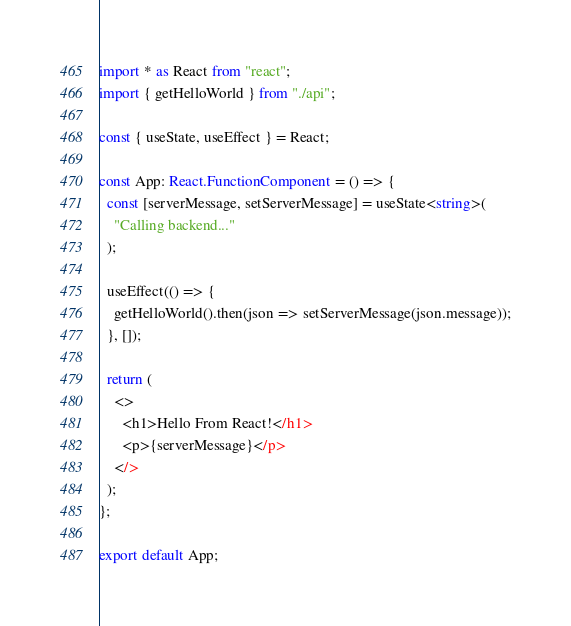<code> <loc_0><loc_0><loc_500><loc_500><_TypeScript_>import * as React from "react";
import { getHelloWorld } from "./api";

const { useState, useEffect } = React;

const App: React.FunctionComponent = () => {
  const [serverMessage, setServerMessage] = useState<string>(
    "Calling backend..."
  );

  useEffect(() => {
    getHelloWorld().then(json => setServerMessage(json.message));
  }, []);

  return (
    <>
      <h1>Hello From React!</h1>
      <p>{serverMessage}</p>
    </>
  );
};

export default App;
</code> 